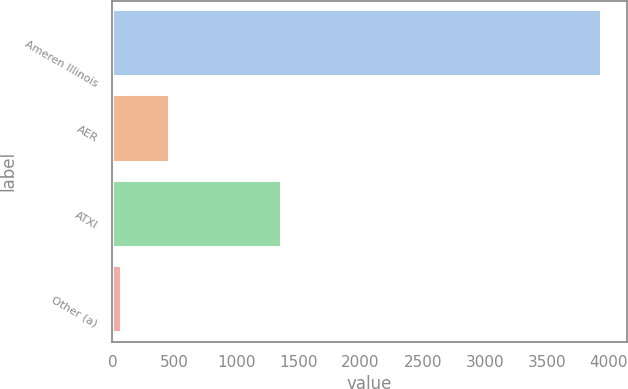<chart> <loc_0><loc_0><loc_500><loc_500><bar_chart><fcel>Ameren Illinois<fcel>AER<fcel>ATXI<fcel>Other (a)<nl><fcel>3945<fcel>462<fcel>1370<fcel>75<nl></chart> 